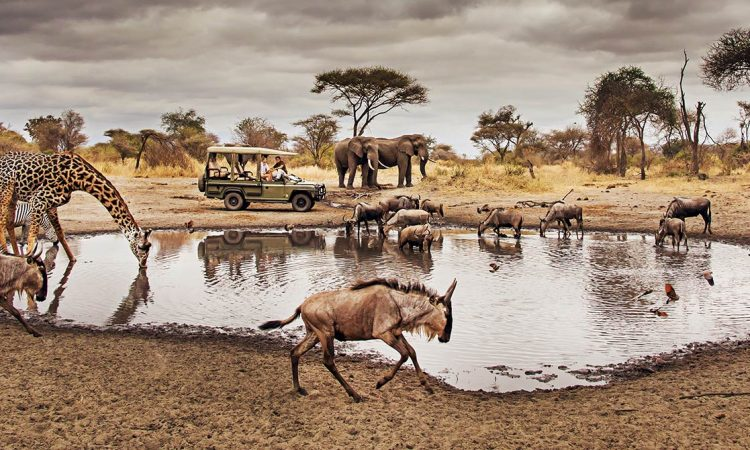Write a detailed description of the given image. This image captures a moment from a safari tour in the world-renowned Serengeti National Park in Tanzania. The perspective is from a low angle, providing a ground-level view of the scene. A group of animals, native to the African savannah, have congregated around a watering hole, a vital resource in their habitat. Among them, a giraffe, one of the tallest mammals on Earth, is seen walking towards a safari vehicle parked nearby, perhaps curious about the visitors. The sky overhead is filled with clouds, casting a soft light over the scene. The colors in the image are predominantly earthy tones of brown and gray, reflecting the natural landscape of the Serengeti. 